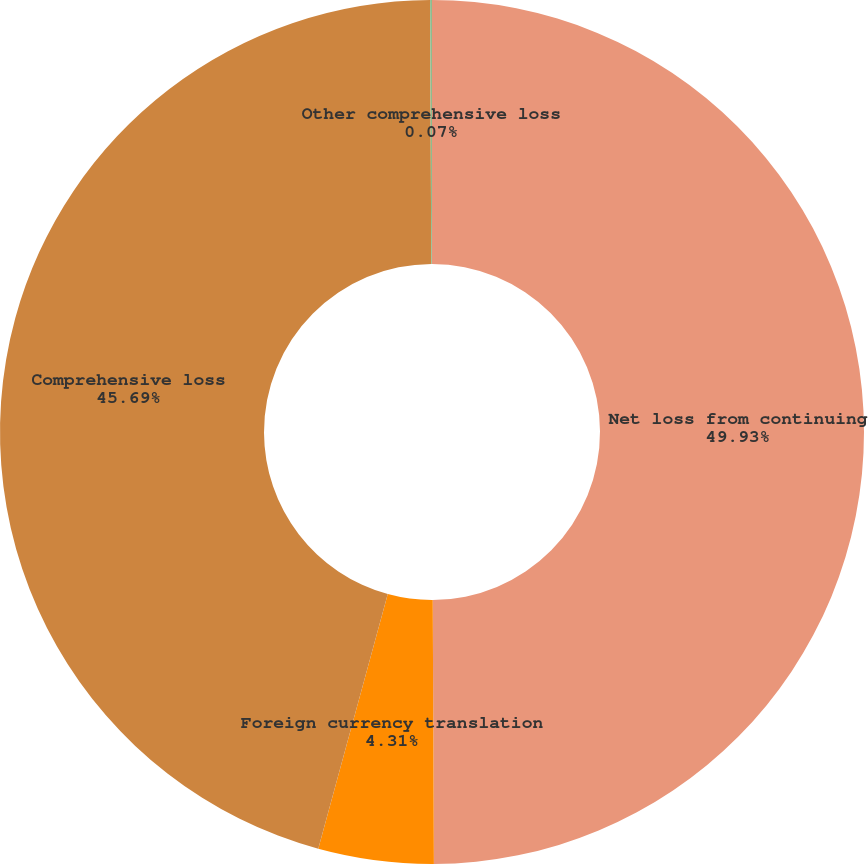Convert chart. <chart><loc_0><loc_0><loc_500><loc_500><pie_chart><fcel>Net loss from continuing<fcel>Foreign currency translation<fcel>Comprehensive loss<fcel>Other comprehensive loss<nl><fcel>49.93%<fcel>4.31%<fcel>45.69%<fcel>0.07%<nl></chart> 